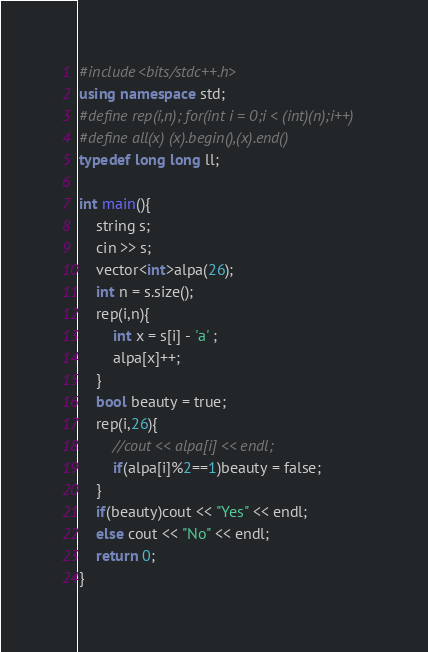Convert code to text. <code><loc_0><loc_0><loc_500><loc_500><_C++_>#include<bits/stdc++.h>
using namespace std;
#define rep(i,n); for(int i = 0;i < (int)(n);i++)
#define all(x) (x).begin(),(x).end()
typedef long long ll;

int main(){
    string s;
    cin >> s;
    vector<int>alpa(26);
    int n = s.size();
    rep(i,n){
        int x = s[i] - 'a' ;
        alpa[x]++;
    }
    bool beauty = true;
    rep(i,26){
        //cout << alpa[i] << endl;
        if(alpa[i]%2==1)beauty = false;
    }
    if(beauty)cout << "Yes" << endl;
    else cout << "No" << endl;
    return 0;
}</code> 